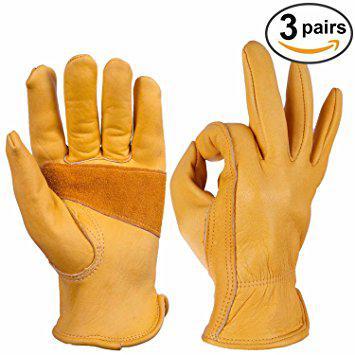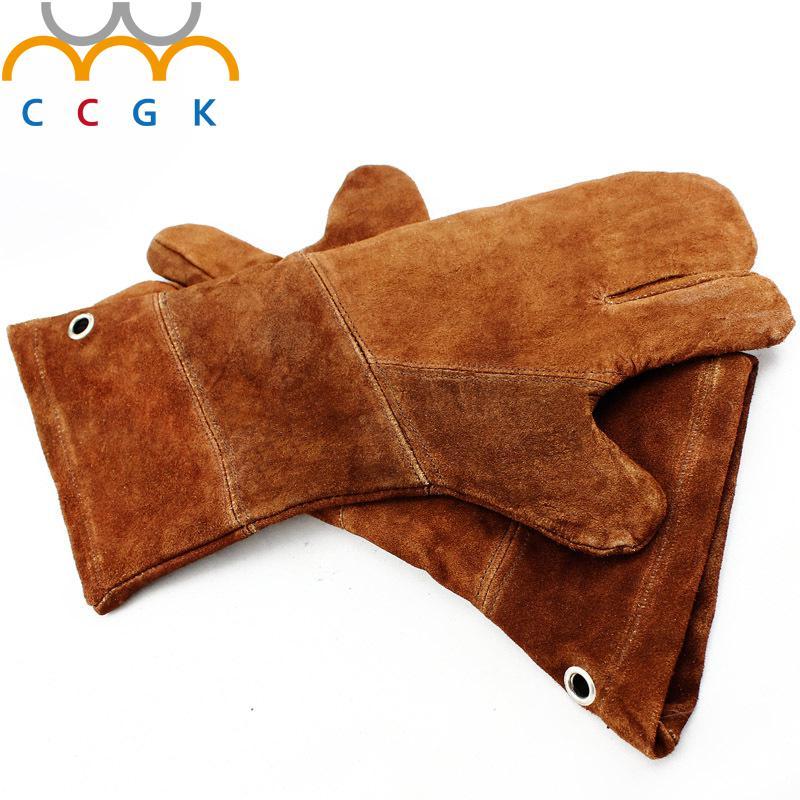The first image is the image on the left, the second image is the image on the right. Evaluate the accuracy of this statement regarding the images: "Each image shows a pair of work gloves and in one of the images the gloves are a single color.". Is it true? Answer yes or no. Yes. The first image is the image on the left, the second image is the image on the right. Assess this claim about the two images: "The gloves all face the same direction.". Correct or not? Answer yes or no. No. 